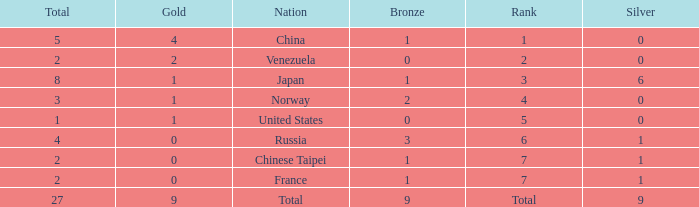What is the average Bronze for rank 3 and total is more than 8? None. 